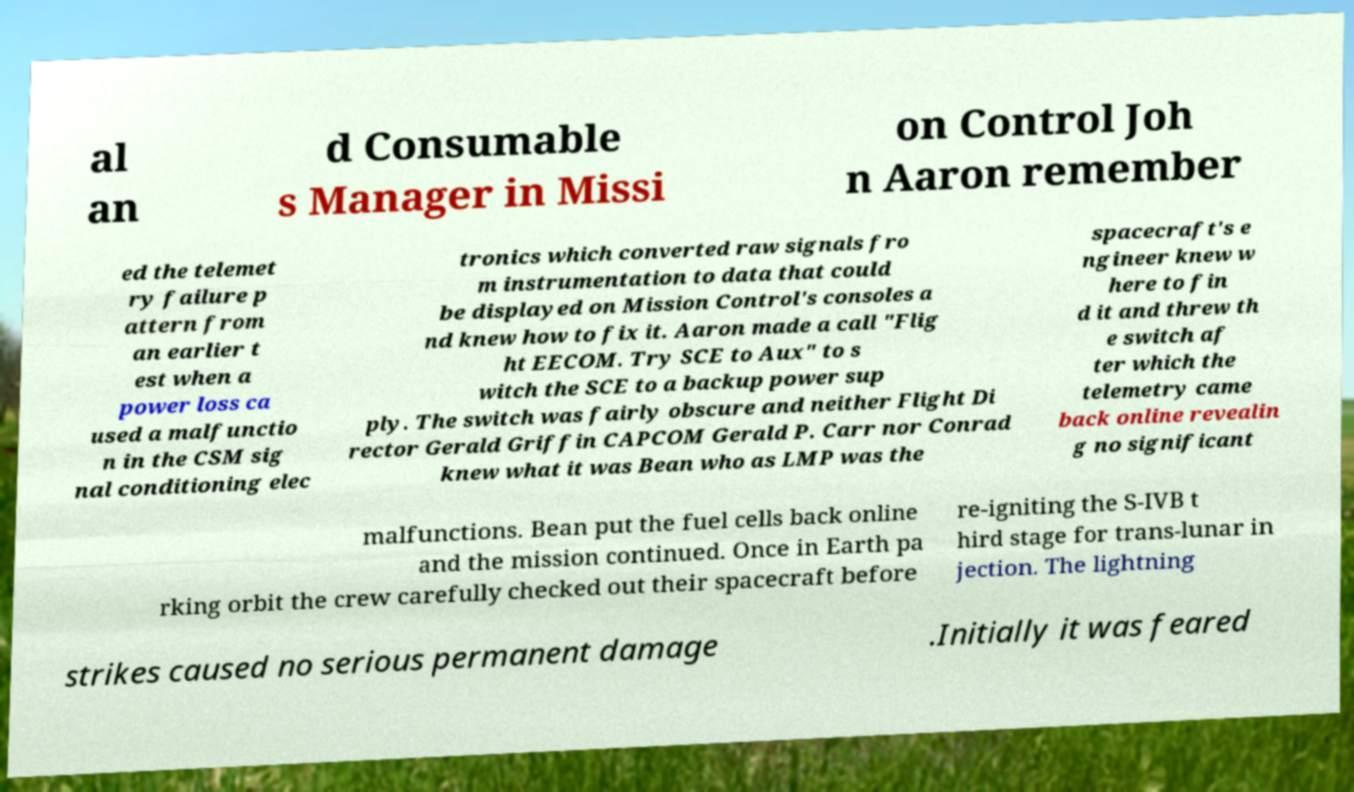Can you read and provide the text displayed in the image?This photo seems to have some interesting text. Can you extract and type it out for me? al an d Consumable s Manager in Missi on Control Joh n Aaron remember ed the telemet ry failure p attern from an earlier t est when a power loss ca used a malfunctio n in the CSM sig nal conditioning elec tronics which converted raw signals fro m instrumentation to data that could be displayed on Mission Control's consoles a nd knew how to fix it. Aaron made a call "Flig ht EECOM. Try SCE to Aux" to s witch the SCE to a backup power sup ply. The switch was fairly obscure and neither Flight Di rector Gerald Griffin CAPCOM Gerald P. Carr nor Conrad knew what it was Bean who as LMP was the spacecraft's e ngineer knew w here to fin d it and threw th e switch af ter which the telemetry came back online revealin g no significant malfunctions. Bean put the fuel cells back online and the mission continued. Once in Earth pa rking orbit the crew carefully checked out their spacecraft before re-igniting the S-IVB t hird stage for trans-lunar in jection. The lightning strikes caused no serious permanent damage .Initially it was feared 